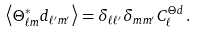<formula> <loc_0><loc_0><loc_500><loc_500>\left < \Theta _ { \ell m } ^ { * } d _ { \ell ^ { \prime } m ^ { \prime } } \right > = \delta _ { \ell \ell ^ { \prime } } \delta _ { m m ^ { \prime } } C _ { \ell } ^ { \Theta d } \, .</formula> 